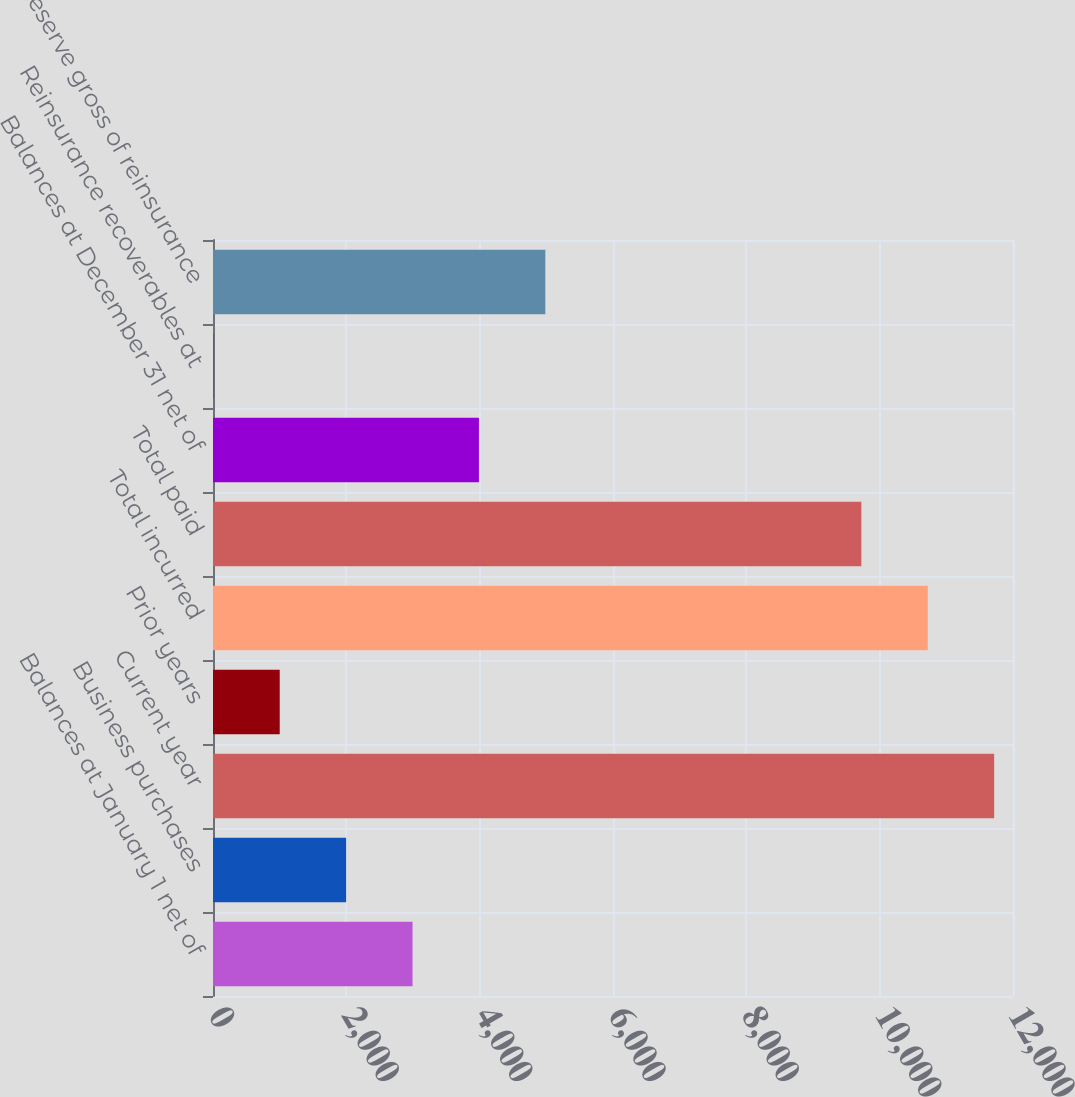Convert chart. <chart><loc_0><loc_0><loc_500><loc_500><bar_chart><fcel>Balances at January 1 net of<fcel>Business purchases<fcel>Current year<fcel>Prior years<fcel>Total incurred<fcel>Total paid<fcel>Balances at December 31 net of<fcel>Reinsurance recoverables at<fcel>Reserve gross of reinsurance<nl><fcel>2992.89<fcel>1996.86<fcel>11717.4<fcel>1000.83<fcel>10721.3<fcel>9725.3<fcel>3988.92<fcel>4.8<fcel>4984.95<nl></chart> 